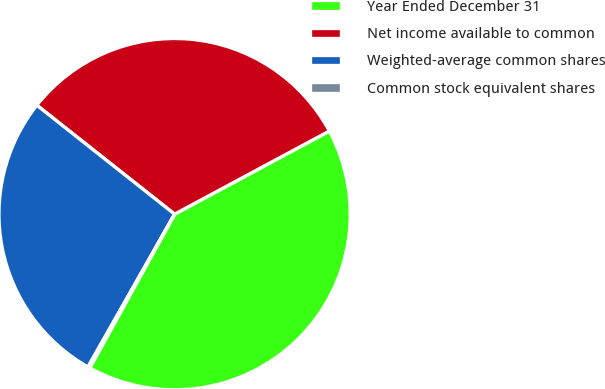<chart> <loc_0><loc_0><loc_500><loc_500><pie_chart><fcel>Year Ended December 31<fcel>Net income available to common<fcel>Weighted-average common shares<fcel>Common stock equivalent shares<nl><fcel>40.87%<fcel>31.51%<fcel>27.44%<fcel>0.18%<nl></chart> 